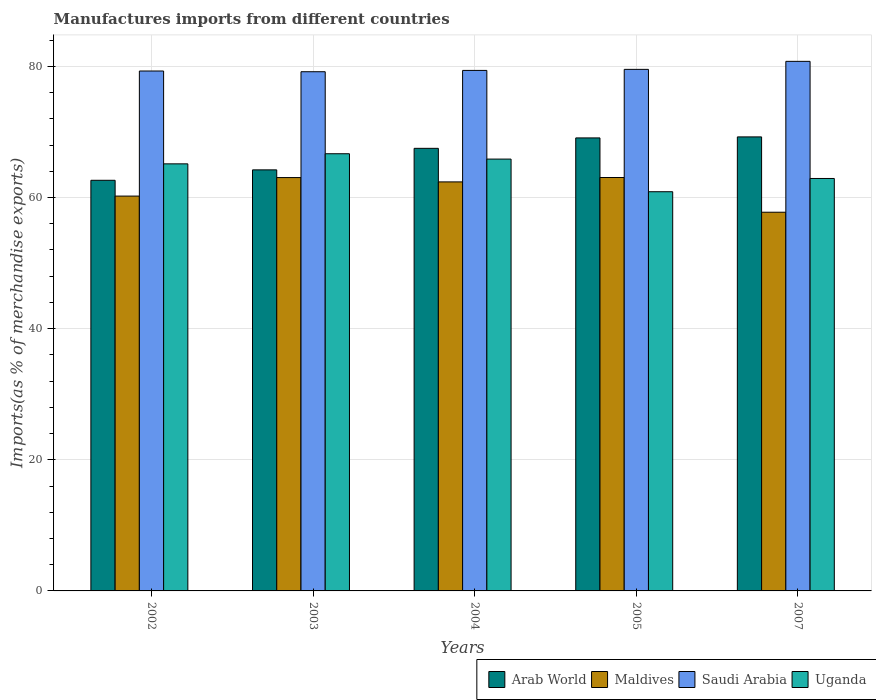How many groups of bars are there?
Your response must be concise. 5. Are the number of bars per tick equal to the number of legend labels?
Your response must be concise. Yes. How many bars are there on the 2nd tick from the left?
Provide a short and direct response. 4. What is the label of the 3rd group of bars from the left?
Provide a succinct answer. 2004. In how many cases, is the number of bars for a given year not equal to the number of legend labels?
Keep it short and to the point. 0. What is the percentage of imports to different countries in Uganda in 2005?
Provide a succinct answer. 60.88. Across all years, what is the maximum percentage of imports to different countries in Arab World?
Give a very brief answer. 69.24. Across all years, what is the minimum percentage of imports to different countries in Arab World?
Your answer should be very brief. 62.62. In which year was the percentage of imports to different countries in Saudi Arabia minimum?
Make the answer very short. 2003. What is the total percentage of imports to different countries in Uganda in the graph?
Offer a terse response. 321.44. What is the difference between the percentage of imports to different countries in Saudi Arabia in 2004 and that in 2005?
Ensure brevity in your answer.  -0.16. What is the difference between the percentage of imports to different countries in Saudi Arabia in 2005 and the percentage of imports to different countries in Maldives in 2004?
Offer a very short reply. 17.16. What is the average percentage of imports to different countries in Arab World per year?
Make the answer very short. 66.53. In the year 2003, what is the difference between the percentage of imports to different countries in Saudi Arabia and percentage of imports to different countries in Maldives?
Give a very brief answer. 16.14. In how many years, is the percentage of imports to different countries in Arab World greater than 4 %?
Ensure brevity in your answer.  5. What is the ratio of the percentage of imports to different countries in Arab World in 2003 to that in 2005?
Provide a short and direct response. 0.93. Is the percentage of imports to different countries in Arab World in 2003 less than that in 2004?
Make the answer very short. Yes. Is the difference between the percentage of imports to different countries in Saudi Arabia in 2002 and 2005 greater than the difference between the percentage of imports to different countries in Maldives in 2002 and 2005?
Provide a short and direct response. Yes. What is the difference between the highest and the second highest percentage of imports to different countries in Arab World?
Your answer should be very brief. 0.15. What is the difference between the highest and the lowest percentage of imports to different countries in Uganda?
Make the answer very short. 5.79. In how many years, is the percentage of imports to different countries in Arab World greater than the average percentage of imports to different countries in Arab World taken over all years?
Keep it short and to the point. 3. Is it the case that in every year, the sum of the percentage of imports to different countries in Maldives and percentage of imports to different countries in Uganda is greater than the sum of percentage of imports to different countries in Saudi Arabia and percentage of imports to different countries in Arab World?
Keep it short and to the point. No. What does the 3rd bar from the left in 2007 represents?
Provide a succinct answer. Saudi Arabia. What does the 1st bar from the right in 2005 represents?
Give a very brief answer. Uganda. Are all the bars in the graph horizontal?
Your answer should be very brief. No. Are the values on the major ticks of Y-axis written in scientific E-notation?
Provide a short and direct response. No. Does the graph contain grids?
Make the answer very short. Yes. Where does the legend appear in the graph?
Offer a terse response. Bottom right. How many legend labels are there?
Offer a very short reply. 4. How are the legend labels stacked?
Offer a very short reply. Horizontal. What is the title of the graph?
Provide a succinct answer. Manufactures imports from different countries. What is the label or title of the X-axis?
Your answer should be compact. Years. What is the label or title of the Y-axis?
Provide a succinct answer. Imports(as % of merchandise exports). What is the Imports(as % of merchandise exports) of Arab World in 2002?
Provide a succinct answer. 62.62. What is the Imports(as % of merchandise exports) of Maldives in 2002?
Offer a very short reply. 60.22. What is the Imports(as % of merchandise exports) of Saudi Arabia in 2002?
Give a very brief answer. 79.29. What is the Imports(as % of merchandise exports) in Uganda in 2002?
Provide a succinct answer. 65.13. What is the Imports(as % of merchandise exports) of Arab World in 2003?
Ensure brevity in your answer.  64.22. What is the Imports(as % of merchandise exports) in Maldives in 2003?
Your answer should be very brief. 63.04. What is the Imports(as % of merchandise exports) of Saudi Arabia in 2003?
Your answer should be compact. 79.18. What is the Imports(as % of merchandise exports) in Uganda in 2003?
Keep it short and to the point. 66.67. What is the Imports(as % of merchandise exports) in Arab World in 2004?
Your answer should be compact. 67.5. What is the Imports(as % of merchandise exports) in Maldives in 2004?
Provide a succinct answer. 62.38. What is the Imports(as % of merchandise exports) of Saudi Arabia in 2004?
Offer a very short reply. 79.38. What is the Imports(as % of merchandise exports) of Uganda in 2004?
Give a very brief answer. 65.86. What is the Imports(as % of merchandise exports) in Arab World in 2005?
Your answer should be very brief. 69.09. What is the Imports(as % of merchandise exports) of Maldives in 2005?
Give a very brief answer. 63.05. What is the Imports(as % of merchandise exports) of Saudi Arabia in 2005?
Give a very brief answer. 79.54. What is the Imports(as % of merchandise exports) of Uganda in 2005?
Your response must be concise. 60.88. What is the Imports(as % of merchandise exports) in Arab World in 2007?
Keep it short and to the point. 69.24. What is the Imports(as % of merchandise exports) in Maldives in 2007?
Give a very brief answer. 57.75. What is the Imports(as % of merchandise exports) in Saudi Arabia in 2007?
Provide a short and direct response. 80.76. What is the Imports(as % of merchandise exports) of Uganda in 2007?
Give a very brief answer. 62.9. Across all years, what is the maximum Imports(as % of merchandise exports) of Arab World?
Offer a terse response. 69.24. Across all years, what is the maximum Imports(as % of merchandise exports) in Maldives?
Your answer should be very brief. 63.05. Across all years, what is the maximum Imports(as % of merchandise exports) in Saudi Arabia?
Provide a short and direct response. 80.76. Across all years, what is the maximum Imports(as % of merchandise exports) of Uganda?
Provide a succinct answer. 66.67. Across all years, what is the minimum Imports(as % of merchandise exports) in Arab World?
Provide a short and direct response. 62.62. Across all years, what is the minimum Imports(as % of merchandise exports) of Maldives?
Offer a very short reply. 57.75. Across all years, what is the minimum Imports(as % of merchandise exports) in Saudi Arabia?
Provide a short and direct response. 79.18. Across all years, what is the minimum Imports(as % of merchandise exports) in Uganda?
Your response must be concise. 60.88. What is the total Imports(as % of merchandise exports) in Arab World in the graph?
Give a very brief answer. 332.67. What is the total Imports(as % of merchandise exports) in Maldives in the graph?
Provide a succinct answer. 306.44. What is the total Imports(as % of merchandise exports) of Saudi Arabia in the graph?
Offer a very short reply. 398.16. What is the total Imports(as % of merchandise exports) of Uganda in the graph?
Ensure brevity in your answer.  321.44. What is the difference between the Imports(as % of merchandise exports) in Arab World in 2002 and that in 2003?
Provide a short and direct response. -1.59. What is the difference between the Imports(as % of merchandise exports) in Maldives in 2002 and that in 2003?
Keep it short and to the point. -2.82. What is the difference between the Imports(as % of merchandise exports) in Saudi Arabia in 2002 and that in 2003?
Offer a terse response. 0.11. What is the difference between the Imports(as % of merchandise exports) in Uganda in 2002 and that in 2003?
Offer a terse response. -1.54. What is the difference between the Imports(as % of merchandise exports) in Arab World in 2002 and that in 2004?
Offer a very short reply. -4.87. What is the difference between the Imports(as % of merchandise exports) in Maldives in 2002 and that in 2004?
Ensure brevity in your answer.  -2.16. What is the difference between the Imports(as % of merchandise exports) of Saudi Arabia in 2002 and that in 2004?
Ensure brevity in your answer.  -0.09. What is the difference between the Imports(as % of merchandise exports) in Uganda in 2002 and that in 2004?
Offer a very short reply. -0.73. What is the difference between the Imports(as % of merchandise exports) of Arab World in 2002 and that in 2005?
Your answer should be very brief. -6.46. What is the difference between the Imports(as % of merchandise exports) of Maldives in 2002 and that in 2005?
Make the answer very short. -2.83. What is the difference between the Imports(as % of merchandise exports) of Saudi Arabia in 2002 and that in 2005?
Your answer should be compact. -0.25. What is the difference between the Imports(as % of merchandise exports) of Uganda in 2002 and that in 2005?
Provide a short and direct response. 4.25. What is the difference between the Imports(as % of merchandise exports) in Arab World in 2002 and that in 2007?
Provide a short and direct response. -6.62. What is the difference between the Imports(as % of merchandise exports) of Maldives in 2002 and that in 2007?
Make the answer very short. 2.46. What is the difference between the Imports(as % of merchandise exports) of Saudi Arabia in 2002 and that in 2007?
Provide a short and direct response. -1.47. What is the difference between the Imports(as % of merchandise exports) of Uganda in 2002 and that in 2007?
Offer a very short reply. 2.23. What is the difference between the Imports(as % of merchandise exports) in Arab World in 2003 and that in 2004?
Your response must be concise. -3.28. What is the difference between the Imports(as % of merchandise exports) in Maldives in 2003 and that in 2004?
Provide a succinct answer. 0.66. What is the difference between the Imports(as % of merchandise exports) in Saudi Arabia in 2003 and that in 2004?
Provide a short and direct response. -0.2. What is the difference between the Imports(as % of merchandise exports) in Uganda in 2003 and that in 2004?
Provide a succinct answer. 0.82. What is the difference between the Imports(as % of merchandise exports) of Arab World in 2003 and that in 2005?
Offer a terse response. -4.87. What is the difference between the Imports(as % of merchandise exports) of Maldives in 2003 and that in 2005?
Give a very brief answer. -0.01. What is the difference between the Imports(as % of merchandise exports) in Saudi Arabia in 2003 and that in 2005?
Make the answer very short. -0.36. What is the difference between the Imports(as % of merchandise exports) in Uganda in 2003 and that in 2005?
Ensure brevity in your answer.  5.79. What is the difference between the Imports(as % of merchandise exports) of Arab World in 2003 and that in 2007?
Your answer should be very brief. -5.03. What is the difference between the Imports(as % of merchandise exports) in Maldives in 2003 and that in 2007?
Offer a very short reply. 5.28. What is the difference between the Imports(as % of merchandise exports) of Saudi Arabia in 2003 and that in 2007?
Your answer should be very brief. -1.58. What is the difference between the Imports(as % of merchandise exports) of Uganda in 2003 and that in 2007?
Make the answer very short. 3.77. What is the difference between the Imports(as % of merchandise exports) of Arab World in 2004 and that in 2005?
Offer a very short reply. -1.59. What is the difference between the Imports(as % of merchandise exports) of Maldives in 2004 and that in 2005?
Offer a terse response. -0.67. What is the difference between the Imports(as % of merchandise exports) of Saudi Arabia in 2004 and that in 2005?
Give a very brief answer. -0.16. What is the difference between the Imports(as % of merchandise exports) of Uganda in 2004 and that in 2005?
Your answer should be compact. 4.98. What is the difference between the Imports(as % of merchandise exports) in Arab World in 2004 and that in 2007?
Offer a terse response. -1.74. What is the difference between the Imports(as % of merchandise exports) in Maldives in 2004 and that in 2007?
Offer a terse response. 4.63. What is the difference between the Imports(as % of merchandise exports) in Saudi Arabia in 2004 and that in 2007?
Offer a terse response. -1.38. What is the difference between the Imports(as % of merchandise exports) of Uganda in 2004 and that in 2007?
Offer a very short reply. 2.96. What is the difference between the Imports(as % of merchandise exports) of Arab World in 2005 and that in 2007?
Provide a succinct answer. -0.15. What is the difference between the Imports(as % of merchandise exports) in Maldives in 2005 and that in 2007?
Provide a short and direct response. 5.3. What is the difference between the Imports(as % of merchandise exports) in Saudi Arabia in 2005 and that in 2007?
Your answer should be very brief. -1.22. What is the difference between the Imports(as % of merchandise exports) in Uganda in 2005 and that in 2007?
Provide a short and direct response. -2.02. What is the difference between the Imports(as % of merchandise exports) in Arab World in 2002 and the Imports(as % of merchandise exports) in Maldives in 2003?
Give a very brief answer. -0.42. What is the difference between the Imports(as % of merchandise exports) of Arab World in 2002 and the Imports(as % of merchandise exports) of Saudi Arabia in 2003?
Offer a very short reply. -16.56. What is the difference between the Imports(as % of merchandise exports) in Arab World in 2002 and the Imports(as % of merchandise exports) in Uganda in 2003?
Provide a succinct answer. -4.05. What is the difference between the Imports(as % of merchandise exports) in Maldives in 2002 and the Imports(as % of merchandise exports) in Saudi Arabia in 2003?
Provide a short and direct response. -18.97. What is the difference between the Imports(as % of merchandise exports) of Maldives in 2002 and the Imports(as % of merchandise exports) of Uganda in 2003?
Offer a terse response. -6.46. What is the difference between the Imports(as % of merchandise exports) of Saudi Arabia in 2002 and the Imports(as % of merchandise exports) of Uganda in 2003?
Your response must be concise. 12.62. What is the difference between the Imports(as % of merchandise exports) in Arab World in 2002 and the Imports(as % of merchandise exports) in Maldives in 2004?
Your answer should be compact. 0.24. What is the difference between the Imports(as % of merchandise exports) of Arab World in 2002 and the Imports(as % of merchandise exports) of Saudi Arabia in 2004?
Keep it short and to the point. -16.76. What is the difference between the Imports(as % of merchandise exports) in Arab World in 2002 and the Imports(as % of merchandise exports) in Uganda in 2004?
Offer a terse response. -3.23. What is the difference between the Imports(as % of merchandise exports) of Maldives in 2002 and the Imports(as % of merchandise exports) of Saudi Arabia in 2004?
Give a very brief answer. -19.17. What is the difference between the Imports(as % of merchandise exports) in Maldives in 2002 and the Imports(as % of merchandise exports) in Uganda in 2004?
Your answer should be compact. -5.64. What is the difference between the Imports(as % of merchandise exports) of Saudi Arabia in 2002 and the Imports(as % of merchandise exports) of Uganda in 2004?
Ensure brevity in your answer.  13.43. What is the difference between the Imports(as % of merchandise exports) in Arab World in 2002 and the Imports(as % of merchandise exports) in Maldives in 2005?
Keep it short and to the point. -0.43. What is the difference between the Imports(as % of merchandise exports) of Arab World in 2002 and the Imports(as % of merchandise exports) of Saudi Arabia in 2005?
Your response must be concise. -16.92. What is the difference between the Imports(as % of merchandise exports) of Arab World in 2002 and the Imports(as % of merchandise exports) of Uganda in 2005?
Make the answer very short. 1.74. What is the difference between the Imports(as % of merchandise exports) of Maldives in 2002 and the Imports(as % of merchandise exports) of Saudi Arabia in 2005?
Ensure brevity in your answer.  -19.32. What is the difference between the Imports(as % of merchandise exports) in Maldives in 2002 and the Imports(as % of merchandise exports) in Uganda in 2005?
Make the answer very short. -0.66. What is the difference between the Imports(as % of merchandise exports) in Saudi Arabia in 2002 and the Imports(as % of merchandise exports) in Uganda in 2005?
Your response must be concise. 18.41. What is the difference between the Imports(as % of merchandise exports) of Arab World in 2002 and the Imports(as % of merchandise exports) of Maldives in 2007?
Offer a very short reply. 4.87. What is the difference between the Imports(as % of merchandise exports) in Arab World in 2002 and the Imports(as % of merchandise exports) in Saudi Arabia in 2007?
Your answer should be compact. -18.14. What is the difference between the Imports(as % of merchandise exports) of Arab World in 2002 and the Imports(as % of merchandise exports) of Uganda in 2007?
Offer a terse response. -0.28. What is the difference between the Imports(as % of merchandise exports) in Maldives in 2002 and the Imports(as % of merchandise exports) in Saudi Arabia in 2007?
Your response must be concise. -20.55. What is the difference between the Imports(as % of merchandise exports) in Maldives in 2002 and the Imports(as % of merchandise exports) in Uganda in 2007?
Offer a terse response. -2.69. What is the difference between the Imports(as % of merchandise exports) of Saudi Arabia in 2002 and the Imports(as % of merchandise exports) of Uganda in 2007?
Your answer should be very brief. 16.39. What is the difference between the Imports(as % of merchandise exports) of Arab World in 2003 and the Imports(as % of merchandise exports) of Maldives in 2004?
Your response must be concise. 1.84. What is the difference between the Imports(as % of merchandise exports) in Arab World in 2003 and the Imports(as % of merchandise exports) in Saudi Arabia in 2004?
Your answer should be very brief. -15.17. What is the difference between the Imports(as % of merchandise exports) of Arab World in 2003 and the Imports(as % of merchandise exports) of Uganda in 2004?
Your answer should be compact. -1.64. What is the difference between the Imports(as % of merchandise exports) of Maldives in 2003 and the Imports(as % of merchandise exports) of Saudi Arabia in 2004?
Provide a succinct answer. -16.34. What is the difference between the Imports(as % of merchandise exports) in Maldives in 2003 and the Imports(as % of merchandise exports) in Uganda in 2004?
Ensure brevity in your answer.  -2.82. What is the difference between the Imports(as % of merchandise exports) in Saudi Arabia in 2003 and the Imports(as % of merchandise exports) in Uganda in 2004?
Make the answer very short. 13.32. What is the difference between the Imports(as % of merchandise exports) of Arab World in 2003 and the Imports(as % of merchandise exports) of Maldives in 2005?
Offer a very short reply. 1.16. What is the difference between the Imports(as % of merchandise exports) in Arab World in 2003 and the Imports(as % of merchandise exports) in Saudi Arabia in 2005?
Provide a short and direct response. -15.33. What is the difference between the Imports(as % of merchandise exports) of Arab World in 2003 and the Imports(as % of merchandise exports) of Uganda in 2005?
Provide a short and direct response. 3.33. What is the difference between the Imports(as % of merchandise exports) of Maldives in 2003 and the Imports(as % of merchandise exports) of Saudi Arabia in 2005?
Ensure brevity in your answer.  -16.5. What is the difference between the Imports(as % of merchandise exports) of Maldives in 2003 and the Imports(as % of merchandise exports) of Uganda in 2005?
Make the answer very short. 2.16. What is the difference between the Imports(as % of merchandise exports) of Saudi Arabia in 2003 and the Imports(as % of merchandise exports) of Uganda in 2005?
Your answer should be compact. 18.3. What is the difference between the Imports(as % of merchandise exports) of Arab World in 2003 and the Imports(as % of merchandise exports) of Maldives in 2007?
Your answer should be very brief. 6.46. What is the difference between the Imports(as % of merchandise exports) of Arab World in 2003 and the Imports(as % of merchandise exports) of Saudi Arabia in 2007?
Keep it short and to the point. -16.55. What is the difference between the Imports(as % of merchandise exports) of Arab World in 2003 and the Imports(as % of merchandise exports) of Uganda in 2007?
Make the answer very short. 1.31. What is the difference between the Imports(as % of merchandise exports) of Maldives in 2003 and the Imports(as % of merchandise exports) of Saudi Arabia in 2007?
Make the answer very short. -17.72. What is the difference between the Imports(as % of merchandise exports) of Maldives in 2003 and the Imports(as % of merchandise exports) of Uganda in 2007?
Ensure brevity in your answer.  0.14. What is the difference between the Imports(as % of merchandise exports) of Saudi Arabia in 2003 and the Imports(as % of merchandise exports) of Uganda in 2007?
Make the answer very short. 16.28. What is the difference between the Imports(as % of merchandise exports) in Arab World in 2004 and the Imports(as % of merchandise exports) in Maldives in 2005?
Your answer should be compact. 4.45. What is the difference between the Imports(as % of merchandise exports) in Arab World in 2004 and the Imports(as % of merchandise exports) in Saudi Arabia in 2005?
Provide a succinct answer. -12.04. What is the difference between the Imports(as % of merchandise exports) in Arab World in 2004 and the Imports(as % of merchandise exports) in Uganda in 2005?
Keep it short and to the point. 6.62. What is the difference between the Imports(as % of merchandise exports) of Maldives in 2004 and the Imports(as % of merchandise exports) of Saudi Arabia in 2005?
Give a very brief answer. -17.16. What is the difference between the Imports(as % of merchandise exports) in Maldives in 2004 and the Imports(as % of merchandise exports) in Uganda in 2005?
Make the answer very short. 1.5. What is the difference between the Imports(as % of merchandise exports) in Saudi Arabia in 2004 and the Imports(as % of merchandise exports) in Uganda in 2005?
Give a very brief answer. 18.5. What is the difference between the Imports(as % of merchandise exports) in Arab World in 2004 and the Imports(as % of merchandise exports) in Maldives in 2007?
Offer a very short reply. 9.74. What is the difference between the Imports(as % of merchandise exports) of Arab World in 2004 and the Imports(as % of merchandise exports) of Saudi Arabia in 2007?
Give a very brief answer. -13.27. What is the difference between the Imports(as % of merchandise exports) of Arab World in 2004 and the Imports(as % of merchandise exports) of Uganda in 2007?
Your answer should be very brief. 4.6. What is the difference between the Imports(as % of merchandise exports) in Maldives in 2004 and the Imports(as % of merchandise exports) in Saudi Arabia in 2007?
Your answer should be very brief. -18.38. What is the difference between the Imports(as % of merchandise exports) in Maldives in 2004 and the Imports(as % of merchandise exports) in Uganda in 2007?
Offer a terse response. -0.52. What is the difference between the Imports(as % of merchandise exports) of Saudi Arabia in 2004 and the Imports(as % of merchandise exports) of Uganda in 2007?
Ensure brevity in your answer.  16.48. What is the difference between the Imports(as % of merchandise exports) of Arab World in 2005 and the Imports(as % of merchandise exports) of Maldives in 2007?
Offer a terse response. 11.33. What is the difference between the Imports(as % of merchandise exports) in Arab World in 2005 and the Imports(as % of merchandise exports) in Saudi Arabia in 2007?
Your answer should be very brief. -11.68. What is the difference between the Imports(as % of merchandise exports) in Arab World in 2005 and the Imports(as % of merchandise exports) in Uganda in 2007?
Offer a terse response. 6.19. What is the difference between the Imports(as % of merchandise exports) in Maldives in 2005 and the Imports(as % of merchandise exports) in Saudi Arabia in 2007?
Give a very brief answer. -17.71. What is the difference between the Imports(as % of merchandise exports) in Maldives in 2005 and the Imports(as % of merchandise exports) in Uganda in 2007?
Offer a terse response. 0.15. What is the difference between the Imports(as % of merchandise exports) in Saudi Arabia in 2005 and the Imports(as % of merchandise exports) in Uganda in 2007?
Your answer should be compact. 16.64. What is the average Imports(as % of merchandise exports) in Arab World per year?
Provide a short and direct response. 66.53. What is the average Imports(as % of merchandise exports) of Maldives per year?
Provide a succinct answer. 61.29. What is the average Imports(as % of merchandise exports) in Saudi Arabia per year?
Make the answer very short. 79.63. What is the average Imports(as % of merchandise exports) of Uganda per year?
Your answer should be compact. 64.29. In the year 2002, what is the difference between the Imports(as % of merchandise exports) of Arab World and Imports(as % of merchandise exports) of Maldives?
Your answer should be compact. 2.41. In the year 2002, what is the difference between the Imports(as % of merchandise exports) in Arab World and Imports(as % of merchandise exports) in Saudi Arabia?
Your answer should be compact. -16.67. In the year 2002, what is the difference between the Imports(as % of merchandise exports) of Arab World and Imports(as % of merchandise exports) of Uganda?
Give a very brief answer. -2.51. In the year 2002, what is the difference between the Imports(as % of merchandise exports) of Maldives and Imports(as % of merchandise exports) of Saudi Arabia?
Offer a very short reply. -19.08. In the year 2002, what is the difference between the Imports(as % of merchandise exports) of Maldives and Imports(as % of merchandise exports) of Uganda?
Keep it short and to the point. -4.91. In the year 2002, what is the difference between the Imports(as % of merchandise exports) in Saudi Arabia and Imports(as % of merchandise exports) in Uganda?
Offer a very short reply. 14.16. In the year 2003, what is the difference between the Imports(as % of merchandise exports) of Arab World and Imports(as % of merchandise exports) of Maldives?
Ensure brevity in your answer.  1.18. In the year 2003, what is the difference between the Imports(as % of merchandise exports) of Arab World and Imports(as % of merchandise exports) of Saudi Arabia?
Your response must be concise. -14.97. In the year 2003, what is the difference between the Imports(as % of merchandise exports) in Arab World and Imports(as % of merchandise exports) in Uganda?
Provide a short and direct response. -2.46. In the year 2003, what is the difference between the Imports(as % of merchandise exports) of Maldives and Imports(as % of merchandise exports) of Saudi Arabia?
Keep it short and to the point. -16.14. In the year 2003, what is the difference between the Imports(as % of merchandise exports) of Maldives and Imports(as % of merchandise exports) of Uganda?
Make the answer very short. -3.63. In the year 2003, what is the difference between the Imports(as % of merchandise exports) in Saudi Arabia and Imports(as % of merchandise exports) in Uganda?
Offer a very short reply. 12.51. In the year 2004, what is the difference between the Imports(as % of merchandise exports) of Arab World and Imports(as % of merchandise exports) of Maldives?
Ensure brevity in your answer.  5.12. In the year 2004, what is the difference between the Imports(as % of merchandise exports) of Arab World and Imports(as % of merchandise exports) of Saudi Arabia?
Keep it short and to the point. -11.88. In the year 2004, what is the difference between the Imports(as % of merchandise exports) in Arab World and Imports(as % of merchandise exports) in Uganda?
Your response must be concise. 1.64. In the year 2004, what is the difference between the Imports(as % of merchandise exports) of Maldives and Imports(as % of merchandise exports) of Saudi Arabia?
Make the answer very short. -17. In the year 2004, what is the difference between the Imports(as % of merchandise exports) of Maldives and Imports(as % of merchandise exports) of Uganda?
Your answer should be compact. -3.48. In the year 2004, what is the difference between the Imports(as % of merchandise exports) of Saudi Arabia and Imports(as % of merchandise exports) of Uganda?
Your answer should be compact. 13.52. In the year 2005, what is the difference between the Imports(as % of merchandise exports) in Arab World and Imports(as % of merchandise exports) in Maldives?
Your response must be concise. 6.04. In the year 2005, what is the difference between the Imports(as % of merchandise exports) in Arab World and Imports(as % of merchandise exports) in Saudi Arabia?
Keep it short and to the point. -10.45. In the year 2005, what is the difference between the Imports(as % of merchandise exports) in Arab World and Imports(as % of merchandise exports) in Uganda?
Provide a succinct answer. 8.21. In the year 2005, what is the difference between the Imports(as % of merchandise exports) in Maldives and Imports(as % of merchandise exports) in Saudi Arabia?
Your answer should be compact. -16.49. In the year 2005, what is the difference between the Imports(as % of merchandise exports) in Maldives and Imports(as % of merchandise exports) in Uganda?
Your response must be concise. 2.17. In the year 2005, what is the difference between the Imports(as % of merchandise exports) of Saudi Arabia and Imports(as % of merchandise exports) of Uganda?
Make the answer very short. 18.66. In the year 2007, what is the difference between the Imports(as % of merchandise exports) of Arab World and Imports(as % of merchandise exports) of Maldives?
Your answer should be compact. 11.49. In the year 2007, what is the difference between the Imports(as % of merchandise exports) in Arab World and Imports(as % of merchandise exports) in Saudi Arabia?
Your answer should be compact. -11.52. In the year 2007, what is the difference between the Imports(as % of merchandise exports) of Arab World and Imports(as % of merchandise exports) of Uganda?
Keep it short and to the point. 6.34. In the year 2007, what is the difference between the Imports(as % of merchandise exports) in Maldives and Imports(as % of merchandise exports) in Saudi Arabia?
Your response must be concise. -23.01. In the year 2007, what is the difference between the Imports(as % of merchandise exports) in Maldives and Imports(as % of merchandise exports) in Uganda?
Ensure brevity in your answer.  -5.15. In the year 2007, what is the difference between the Imports(as % of merchandise exports) of Saudi Arabia and Imports(as % of merchandise exports) of Uganda?
Provide a succinct answer. 17.86. What is the ratio of the Imports(as % of merchandise exports) in Arab World in 2002 to that in 2003?
Offer a very short reply. 0.98. What is the ratio of the Imports(as % of merchandise exports) in Maldives in 2002 to that in 2003?
Keep it short and to the point. 0.96. What is the ratio of the Imports(as % of merchandise exports) of Uganda in 2002 to that in 2003?
Your answer should be very brief. 0.98. What is the ratio of the Imports(as % of merchandise exports) of Arab World in 2002 to that in 2004?
Give a very brief answer. 0.93. What is the ratio of the Imports(as % of merchandise exports) in Maldives in 2002 to that in 2004?
Your answer should be compact. 0.97. What is the ratio of the Imports(as % of merchandise exports) in Saudi Arabia in 2002 to that in 2004?
Ensure brevity in your answer.  1. What is the ratio of the Imports(as % of merchandise exports) of Arab World in 2002 to that in 2005?
Give a very brief answer. 0.91. What is the ratio of the Imports(as % of merchandise exports) in Maldives in 2002 to that in 2005?
Provide a short and direct response. 0.95. What is the ratio of the Imports(as % of merchandise exports) of Saudi Arabia in 2002 to that in 2005?
Give a very brief answer. 1. What is the ratio of the Imports(as % of merchandise exports) in Uganda in 2002 to that in 2005?
Provide a short and direct response. 1.07. What is the ratio of the Imports(as % of merchandise exports) in Arab World in 2002 to that in 2007?
Give a very brief answer. 0.9. What is the ratio of the Imports(as % of merchandise exports) in Maldives in 2002 to that in 2007?
Provide a succinct answer. 1.04. What is the ratio of the Imports(as % of merchandise exports) in Saudi Arabia in 2002 to that in 2007?
Your answer should be compact. 0.98. What is the ratio of the Imports(as % of merchandise exports) of Uganda in 2002 to that in 2007?
Ensure brevity in your answer.  1.04. What is the ratio of the Imports(as % of merchandise exports) of Arab World in 2003 to that in 2004?
Provide a short and direct response. 0.95. What is the ratio of the Imports(as % of merchandise exports) in Maldives in 2003 to that in 2004?
Offer a terse response. 1.01. What is the ratio of the Imports(as % of merchandise exports) of Uganda in 2003 to that in 2004?
Offer a terse response. 1.01. What is the ratio of the Imports(as % of merchandise exports) of Arab World in 2003 to that in 2005?
Your answer should be compact. 0.93. What is the ratio of the Imports(as % of merchandise exports) of Maldives in 2003 to that in 2005?
Provide a short and direct response. 1. What is the ratio of the Imports(as % of merchandise exports) of Uganda in 2003 to that in 2005?
Offer a terse response. 1.1. What is the ratio of the Imports(as % of merchandise exports) of Arab World in 2003 to that in 2007?
Make the answer very short. 0.93. What is the ratio of the Imports(as % of merchandise exports) in Maldives in 2003 to that in 2007?
Offer a terse response. 1.09. What is the ratio of the Imports(as % of merchandise exports) of Saudi Arabia in 2003 to that in 2007?
Your answer should be compact. 0.98. What is the ratio of the Imports(as % of merchandise exports) of Uganda in 2003 to that in 2007?
Keep it short and to the point. 1.06. What is the ratio of the Imports(as % of merchandise exports) in Arab World in 2004 to that in 2005?
Ensure brevity in your answer.  0.98. What is the ratio of the Imports(as % of merchandise exports) in Uganda in 2004 to that in 2005?
Your response must be concise. 1.08. What is the ratio of the Imports(as % of merchandise exports) of Arab World in 2004 to that in 2007?
Provide a short and direct response. 0.97. What is the ratio of the Imports(as % of merchandise exports) of Maldives in 2004 to that in 2007?
Make the answer very short. 1.08. What is the ratio of the Imports(as % of merchandise exports) in Saudi Arabia in 2004 to that in 2007?
Your answer should be compact. 0.98. What is the ratio of the Imports(as % of merchandise exports) of Uganda in 2004 to that in 2007?
Provide a short and direct response. 1.05. What is the ratio of the Imports(as % of merchandise exports) of Maldives in 2005 to that in 2007?
Your answer should be very brief. 1.09. What is the ratio of the Imports(as % of merchandise exports) in Saudi Arabia in 2005 to that in 2007?
Offer a very short reply. 0.98. What is the ratio of the Imports(as % of merchandise exports) of Uganda in 2005 to that in 2007?
Keep it short and to the point. 0.97. What is the difference between the highest and the second highest Imports(as % of merchandise exports) of Arab World?
Keep it short and to the point. 0.15. What is the difference between the highest and the second highest Imports(as % of merchandise exports) of Maldives?
Offer a very short reply. 0.01. What is the difference between the highest and the second highest Imports(as % of merchandise exports) in Saudi Arabia?
Give a very brief answer. 1.22. What is the difference between the highest and the second highest Imports(as % of merchandise exports) in Uganda?
Your answer should be compact. 0.82. What is the difference between the highest and the lowest Imports(as % of merchandise exports) of Arab World?
Ensure brevity in your answer.  6.62. What is the difference between the highest and the lowest Imports(as % of merchandise exports) of Maldives?
Your response must be concise. 5.3. What is the difference between the highest and the lowest Imports(as % of merchandise exports) of Saudi Arabia?
Your answer should be compact. 1.58. What is the difference between the highest and the lowest Imports(as % of merchandise exports) of Uganda?
Your answer should be very brief. 5.79. 